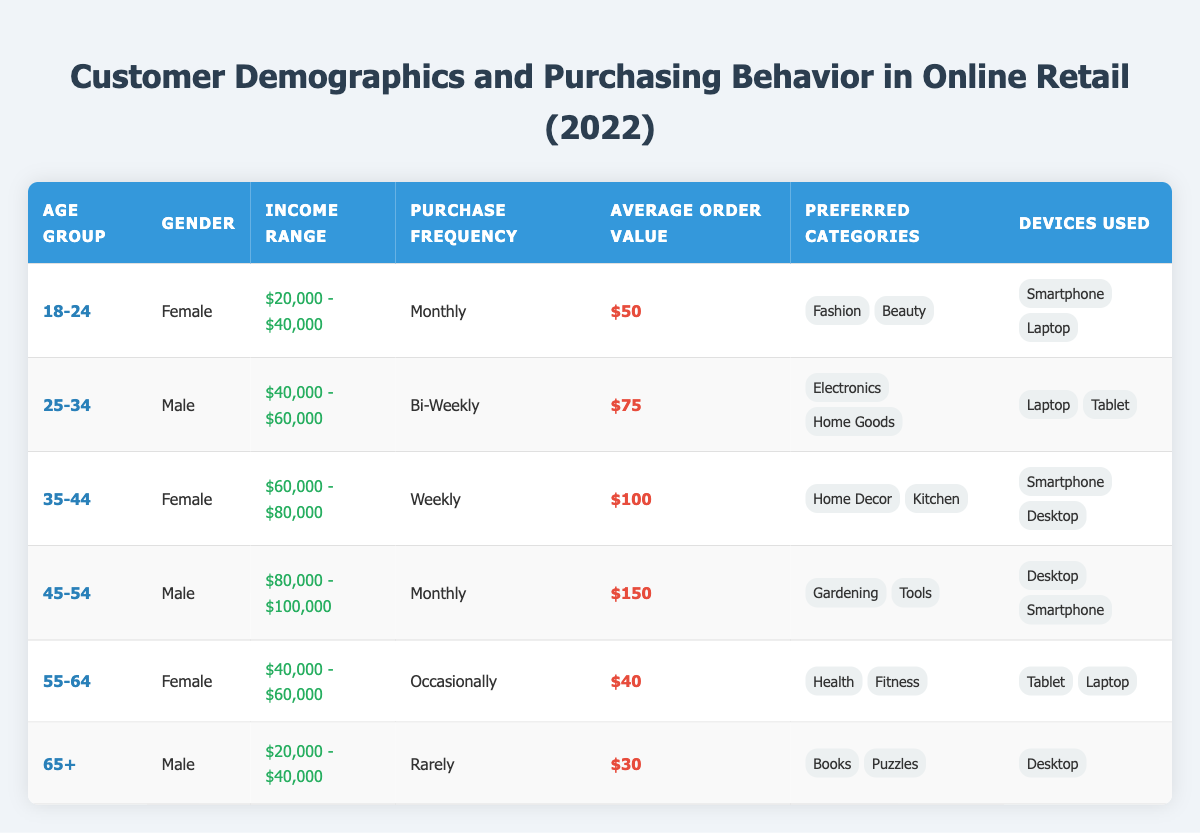What is the average order value for the age group 35-44? The average order value for the age group 35-44 is provided directly in the table as $100.
Answer: $100 How many different devices are used by males aged 65 or older? The age group 65+ contains males who use one device listed in the table: Desktop. Therefore, there is just one device mentioned for this age group.
Answer: 1 Which age group has the highest average order value? To determine this, we compare the average order values: 50 for 18-24, 75 for 25-34, 100 for 35-44, 150 for 45-54, 40 for 55-64, and 30 for 65+. The highest is $150 for the age group 45-54.
Answer: 45-54 Are females more likely to have a monthly purchasing frequency compared to males? In the table, two females (aged 18-24 and 35-44) purchase monthly, and one male (aged 45-54) also purchases monthly. However, females also have a weekly purchase frequency (35-44) compared to only one male with a monthly frequency. Therefore, females are more likely to purchase monthly.
Answer: Yes What is the total average order value for all age groups combined? To find the total average order value, add the values: 50 + 75 + 100 + 150 + 40 + 30 = 445. There are six age groups, so to get the average, divide 445 by 6, resulting in approximately 74.17.
Answer: 74.17 How many age groups have a purchase frequency of 'Occasionally'? The only age group that has a purchase frequency of 'Occasionally' is 55-64, according to the table.
Answer: 1 Is the income range of the 45-54 age group higher or lower than that of the 25-34 age group? The income range for 45-54 is $80,000 - $100,000, which is higher than the range for 25-34 at $40,000 - $60,000, as seen in the table.
Answer: Higher What are the preferred categories for customers aged 55-64? For the age group 55-64, the table shows the preferred categories are Health and Fitness.
Answer: Health, Fitness How many customers aged 18-24 prefer Beauty as a category? From the table, there is only one customer in the 18-24 age group who prefers Beauty.
Answer: 1 